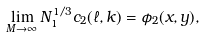Convert formula to latex. <formula><loc_0><loc_0><loc_500><loc_500>\lim _ { M \to \infty } N _ { 1 } ^ { 1 / 3 } c _ { 2 } ( \ell , k ) = \phi _ { 2 } ( x , y ) ,</formula> 